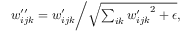<formula> <loc_0><loc_0><loc_500><loc_500>\begin{array} { r } { w _ { i j k } ^ { \prime \prime } = w _ { i j k } ^ { \prime } | d l e / \sqrt { \sum _ { i k } { w _ { i j k } ^ { \prime } } ^ { 2 } + \epsilon } , } \end{array}</formula> 